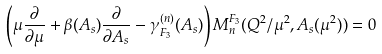Convert formula to latex. <formula><loc_0><loc_0><loc_500><loc_500>\left ( \mu \frac { \partial } { \partial \mu } + \beta ( A _ { s } ) \frac { \partial } { \partial A _ { s } } - \gamma _ { F _ { 3 } } ^ { ( n ) } ( A _ { s } ) \right ) M _ { n } ^ { F _ { 3 } } ( Q ^ { 2 } / \mu ^ { 2 } , A _ { s } ( \mu ^ { 2 } ) ) = 0</formula> 